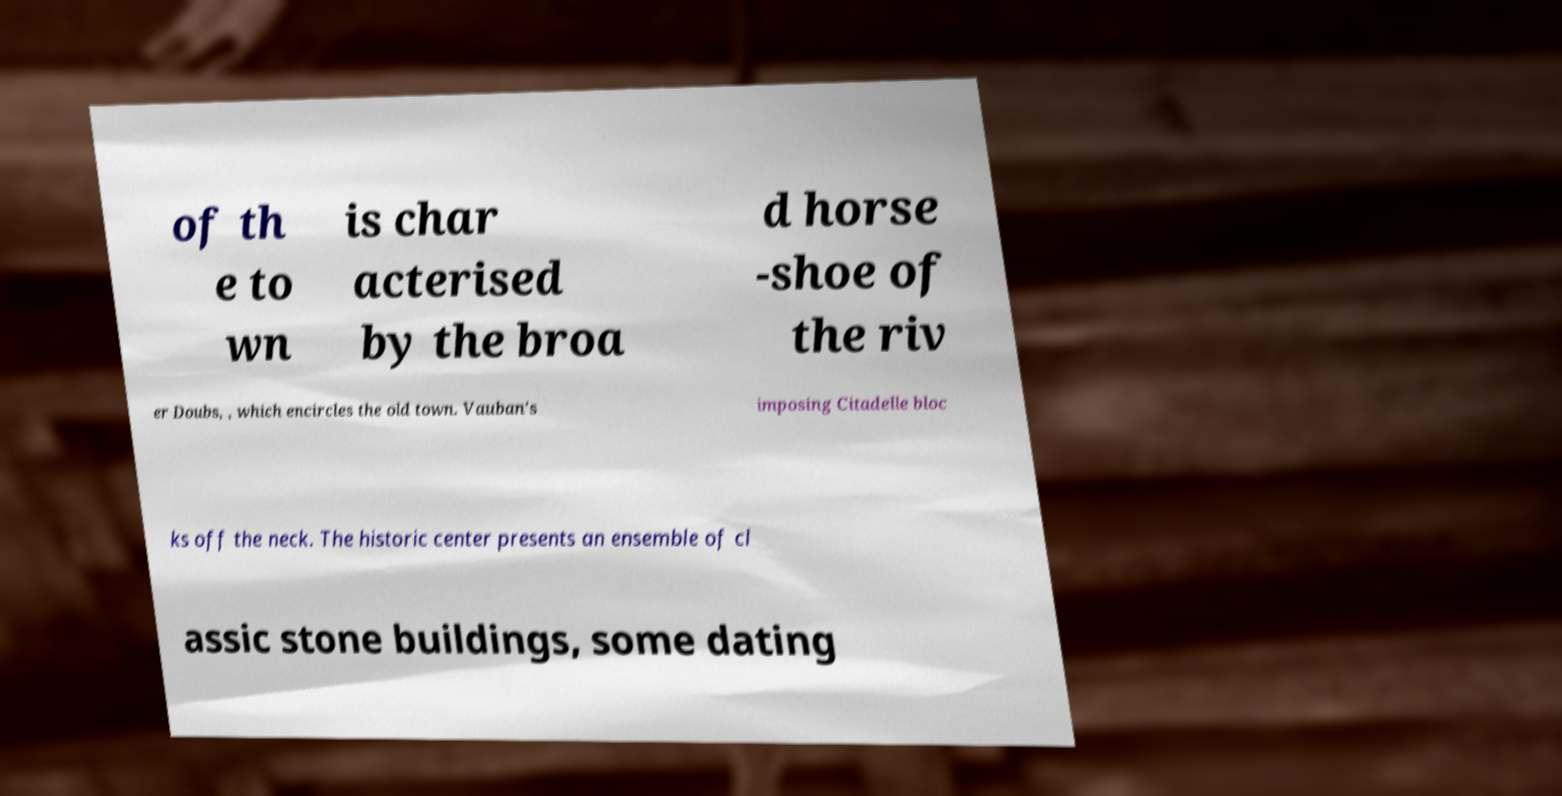I need the written content from this picture converted into text. Can you do that? of th e to wn is char acterised by the broa d horse -shoe of the riv er Doubs, , which encircles the old town. Vauban's imposing Citadelle bloc ks off the neck. The historic center presents an ensemble of cl assic stone buildings, some dating 